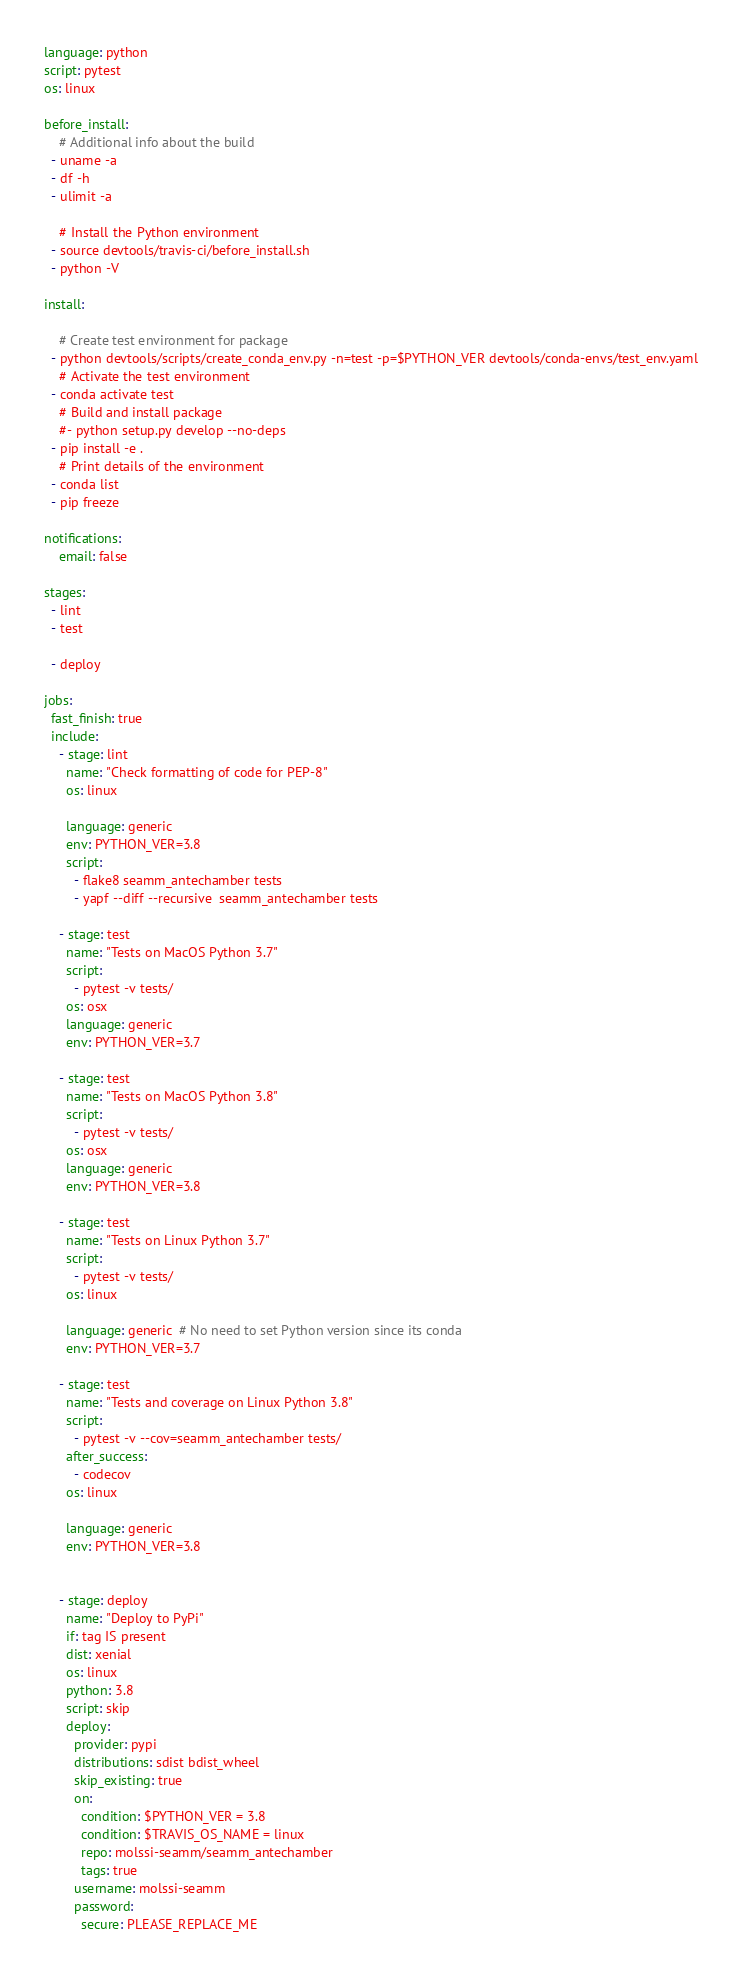<code> <loc_0><loc_0><loc_500><loc_500><_YAML_>language: python
script: pytest
os: linux

before_install:
    # Additional info about the build
  - uname -a
  - df -h
  - ulimit -a

    # Install the Python environment
  - source devtools/travis-ci/before_install.sh
  - python -V

install:

    # Create test environment for package
  - python devtools/scripts/create_conda_env.py -n=test -p=$PYTHON_VER devtools/conda-envs/test_env.yaml
    # Activate the test environment
  - conda activate test
    # Build and install package
    #- python setup.py develop --no-deps
  - pip install -e .
    # Print details of the environment
  - conda list
  - pip freeze

notifications:
    email: false

stages:
  - lint
  - test

  - deploy

jobs:
  fast_finish: true
  include:
    - stage: lint
      name: "Check formatting of code for PEP-8"
      os: linux

      language: generic
      env: PYTHON_VER=3.8
      script:
        - flake8 seamm_antechamber tests
        - yapf --diff --recursive  seamm_antechamber tests

    - stage: test
      name: "Tests on MacOS Python 3.7"
      script:
        - pytest -v tests/
      os: osx
      language: generic
      env: PYTHON_VER=3.7

    - stage: test
      name: "Tests on MacOS Python 3.8"
      script:
        - pytest -v tests/
      os: osx
      language: generic
      env: PYTHON_VER=3.8

    - stage: test
      name: "Tests on Linux Python 3.7"
      script:
        - pytest -v tests/
      os: linux

      language: generic  # No need to set Python version since its conda
      env: PYTHON_VER=3.7

    - stage: test
      name: "Tests and coverage on Linux Python 3.8"
      script:
        - pytest -v --cov=seamm_antechamber tests/
      after_success:
        - codecov
      os: linux

      language: generic
      env: PYTHON_VER=3.8


    - stage: deploy
      name: "Deploy to PyPi"
      if: tag IS present
      dist: xenial
      os: linux
      python: 3.8
      script: skip
      deploy:
        provider: pypi
        distributions: sdist bdist_wheel
        skip_existing: true
        on:
          condition: $PYTHON_VER = 3.8
          condition: $TRAVIS_OS_NAME = linux
          repo: molssi-seamm/seamm_antechamber
          tags: true
        username: molssi-seamm
        password:
          secure: PLEASE_REPLACE_ME
</code> 